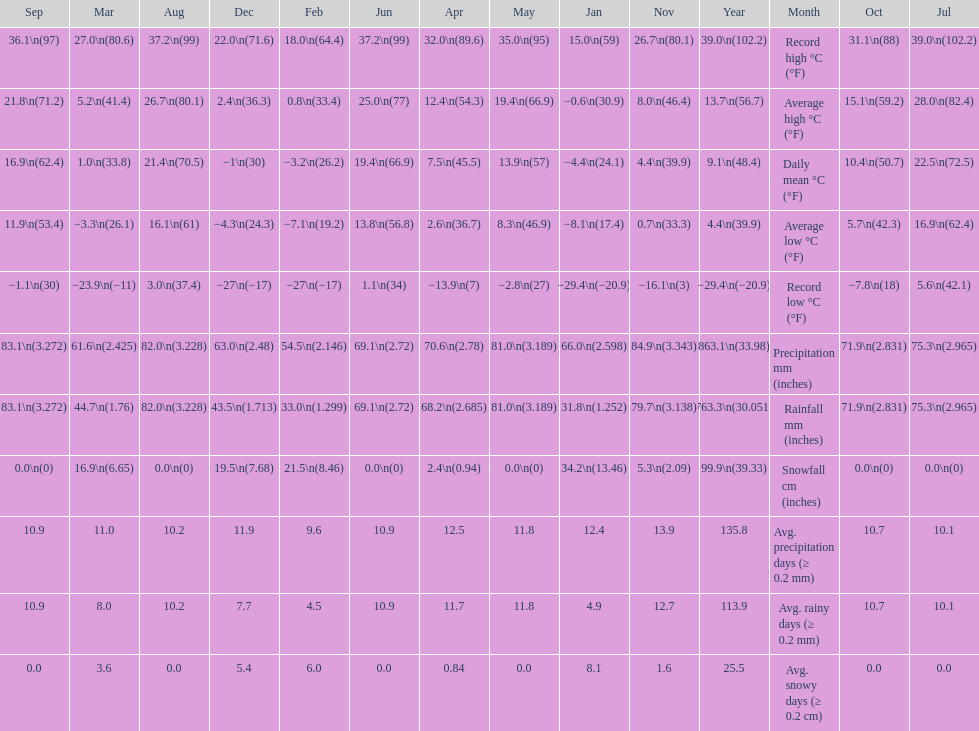Between january, october and december which month had the most rainfall? October. 